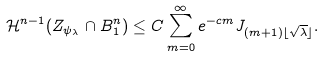Convert formula to latex. <formula><loc_0><loc_0><loc_500><loc_500>\mathcal { H } ^ { n - 1 } ( Z _ { \psi _ { \lambda } } \cap B ^ { n } _ { 1 } ) & \leq C \sum _ { m = 0 } ^ { \infty } e ^ { - c m } J _ { ( m + 1 ) \lfloor \sqrt { \lambda } \rfloor } .</formula> 